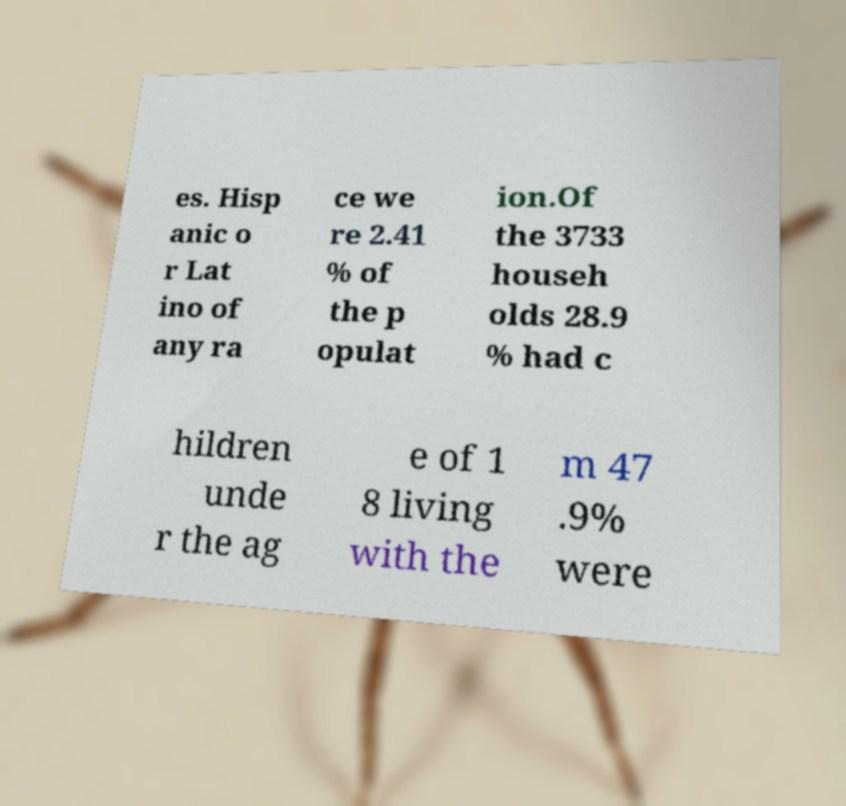Could you extract and type out the text from this image? es. Hisp anic o r Lat ino of any ra ce we re 2.41 % of the p opulat ion.Of the 3733 househ olds 28.9 % had c hildren unde r the ag e of 1 8 living with the m 47 .9% were 